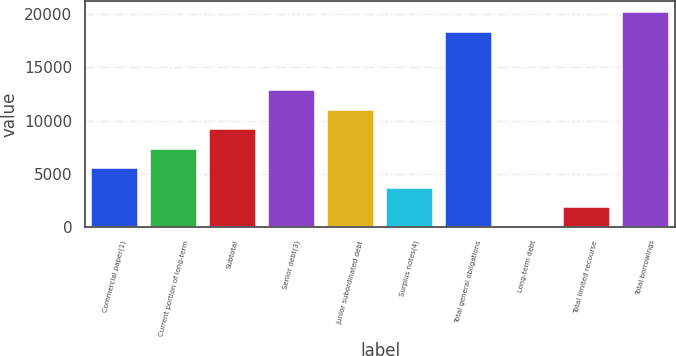Convert chart. <chart><loc_0><loc_0><loc_500><loc_500><bar_chart><fcel>Commercial paper(1)<fcel>Current portion of long-term<fcel>Subtotal<fcel>Senior debt(3)<fcel>Junior subordinated debt<fcel>Surplus notes(4)<fcel>Total general obligations<fcel>Long-term debt<fcel>Total limited recourse<fcel>Total borrowings<nl><fcel>5515.99<fcel>7353.7<fcel>9191.41<fcel>12866.8<fcel>11029.1<fcel>3678.28<fcel>18380<fcel>2.86<fcel>1840.57<fcel>20217.7<nl></chart> 